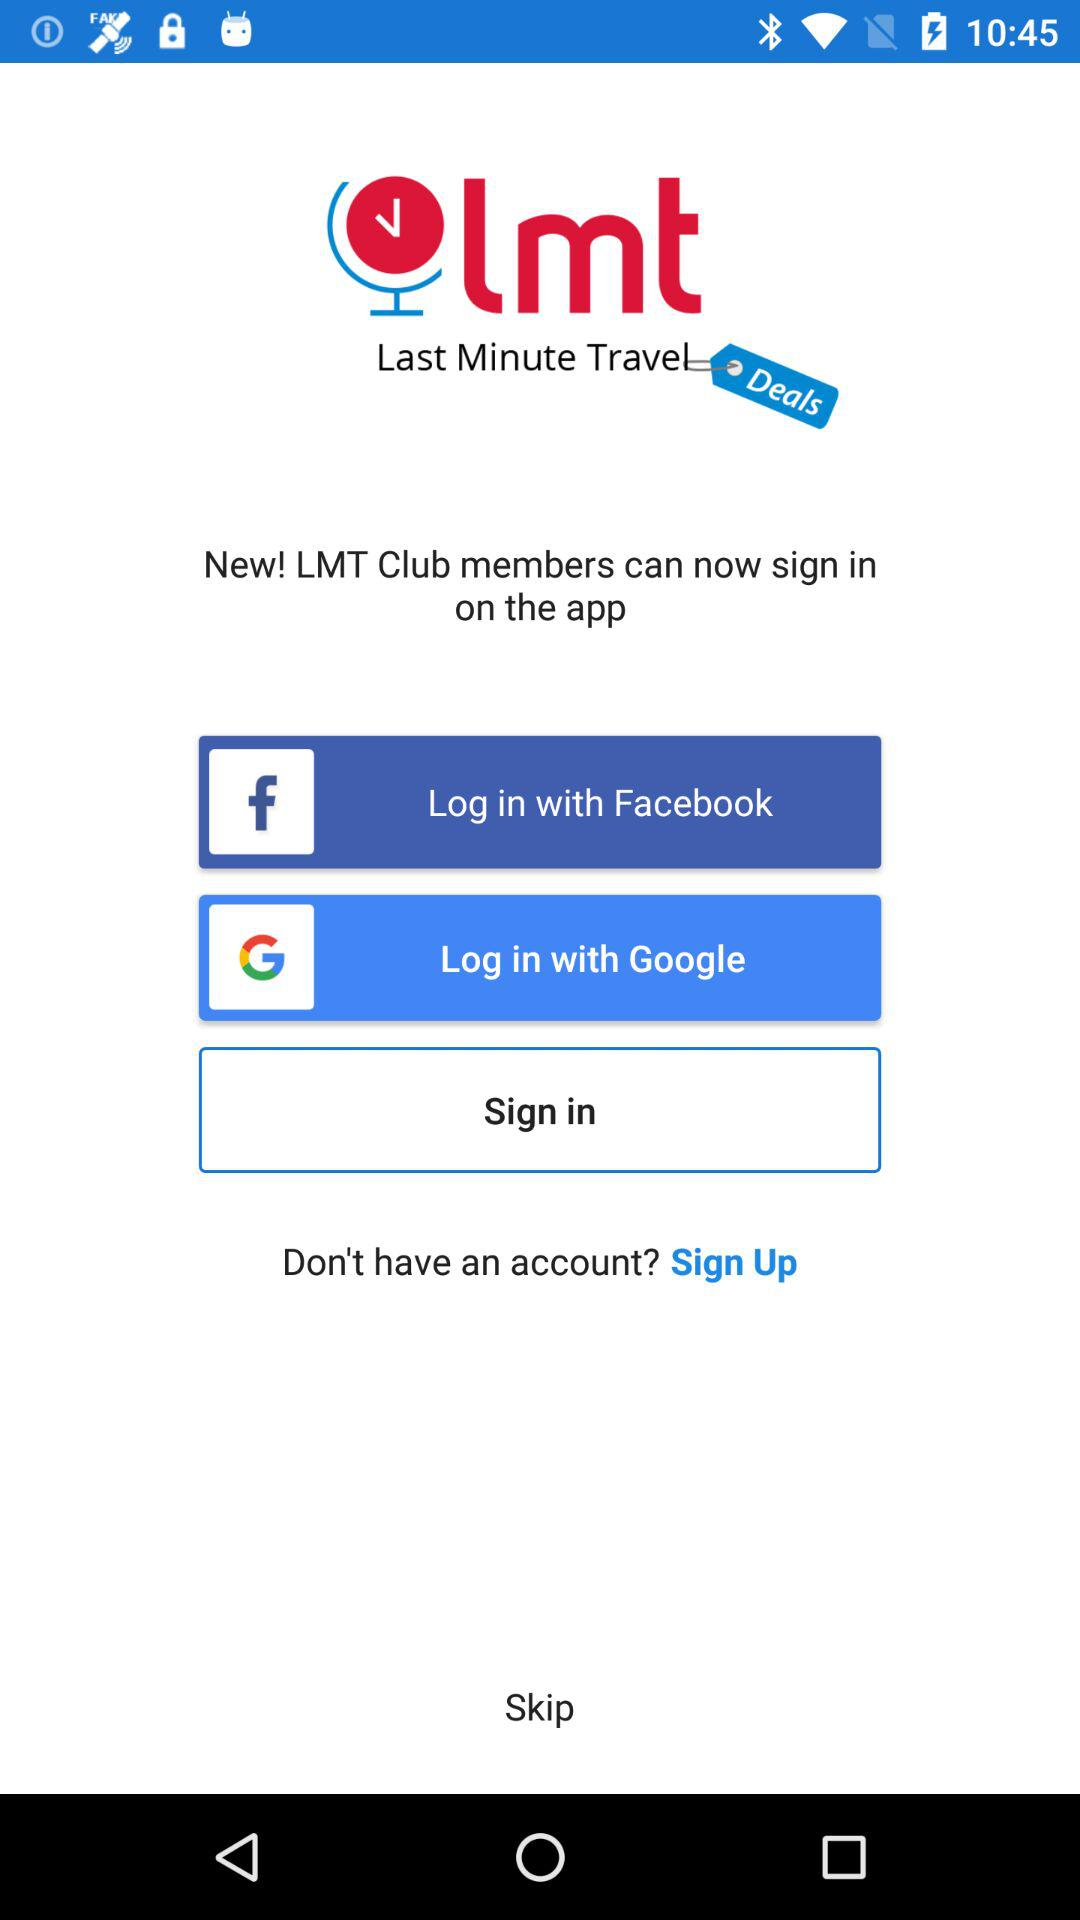What is the full form of LMT? The full form is Last Minute Travel. 